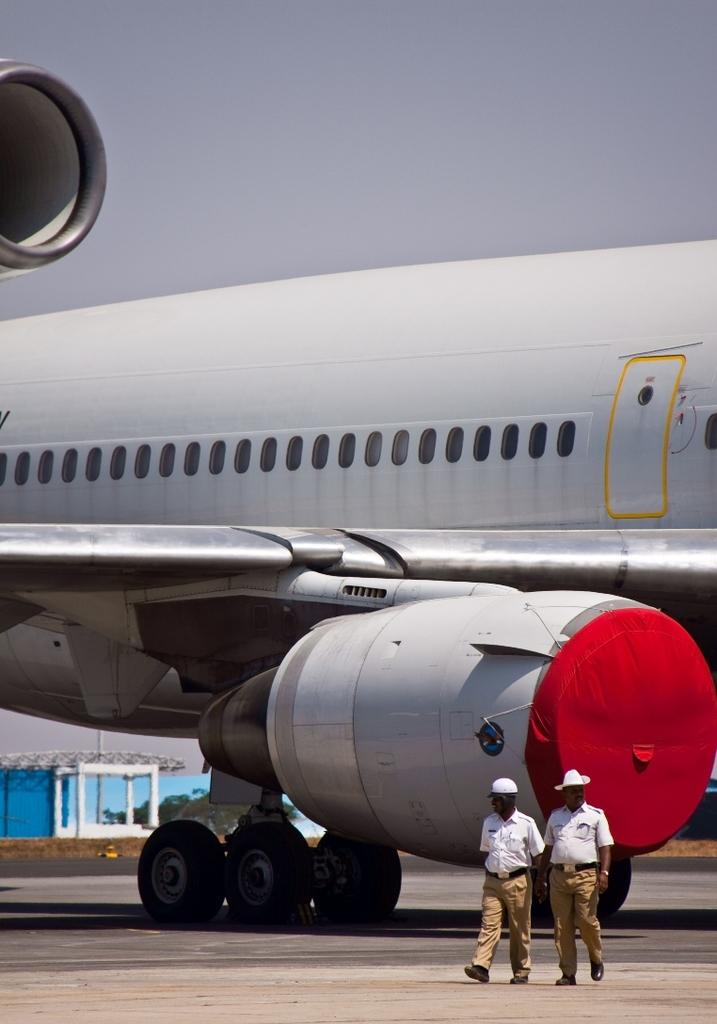How many people are present in the image? There are two people in the image. What is located on the ground in the image? There is an airplane on the ground in the image. What can be seen in the background of the image? There are trees and the sky visible in the background of the image. Can you describe any other objects in the background of the image? There are some unspecified objects in the background of the image. What type of knife is the spy using to cut the airplane in the image? There is no knife or spy present in the image, and the airplane is not being cut. 